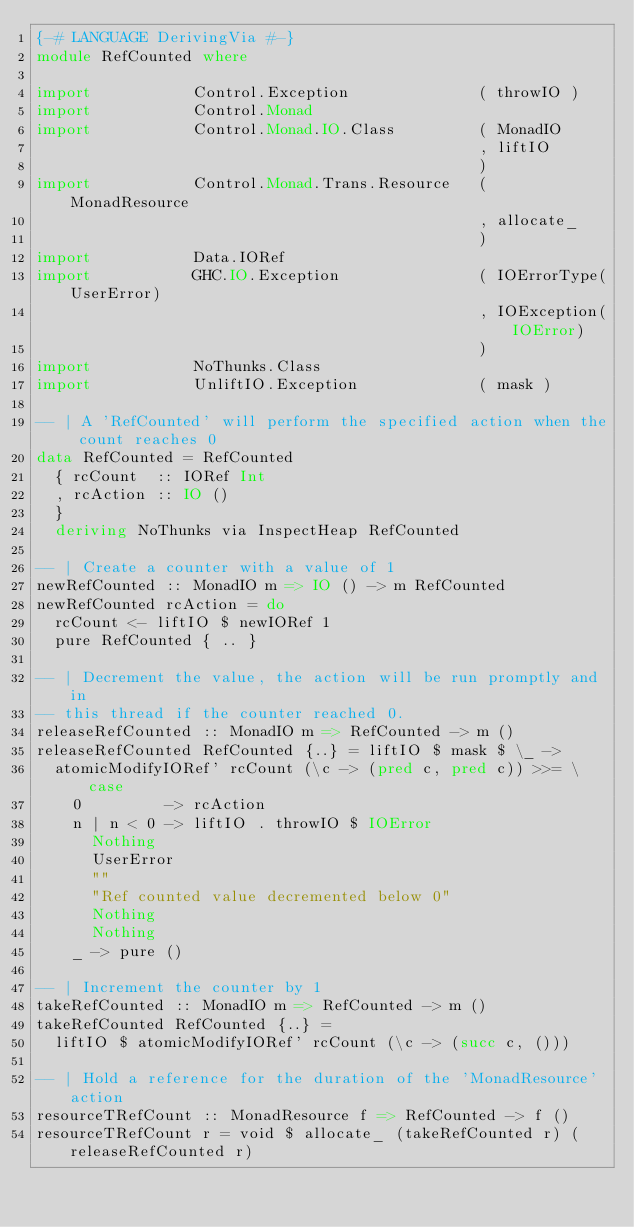<code> <loc_0><loc_0><loc_500><loc_500><_Haskell_>{-# LANGUAGE DerivingVia #-}
module RefCounted where

import           Control.Exception              ( throwIO )
import           Control.Monad
import           Control.Monad.IO.Class         ( MonadIO
                                                , liftIO
                                                )
import           Control.Monad.Trans.Resource   ( MonadResource
                                                , allocate_
                                                )
import           Data.IORef
import           GHC.IO.Exception               ( IOErrorType(UserError)
                                                , IOException(IOError)
                                                )
import           NoThunks.Class
import           UnliftIO.Exception             ( mask )

-- | A 'RefCounted' will perform the specified action when the count reaches 0
data RefCounted = RefCounted
  { rcCount  :: IORef Int
  , rcAction :: IO ()
  }
  deriving NoThunks via InspectHeap RefCounted

-- | Create a counter with a value of 1
newRefCounted :: MonadIO m => IO () -> m RefCounted
newRefCounted rcAction = do
  rcCount <- liftIO $ newIORef 1
  pure RefCounted { .. }

-- | Decrement the value, the action will be run promptly and in
-- this thread if the counter reached 0.
releaseRefCounted :: MonadIO m => RefCounted -> m ()
releaseRefCounted RefCounted {..} = liftIO $ mask $ \_ ->
  atomicModifyIORef' rcCount (\c -> (pred c, pred c)) >>= \case
    0         -> rcAction
    n | n < 0 -> liftIO . throwIO $ IOError
      Nothing
      UserError
      ""
      "Ref counted value decremented below 0"
      Nothing
      Nothing
    _ -> pure ()

-- | Increment the counter by 1
takeRefCounted :: MonadIO m => RefCounted -> m ()
takeRefCounted RefCounted {..} =
  liftIO $ atomicModifyIORef' rcCount (\c -> (succ c, ()))

-- | Hold a reference for the duration of the 'MonadResource' action
resourceTRefCount :: MonadResource f => RefCounted -> f ()
resourceTRefCount r = void $ allocate_ (takeRefCounted r) (releaseRefCounted r)
</code> 